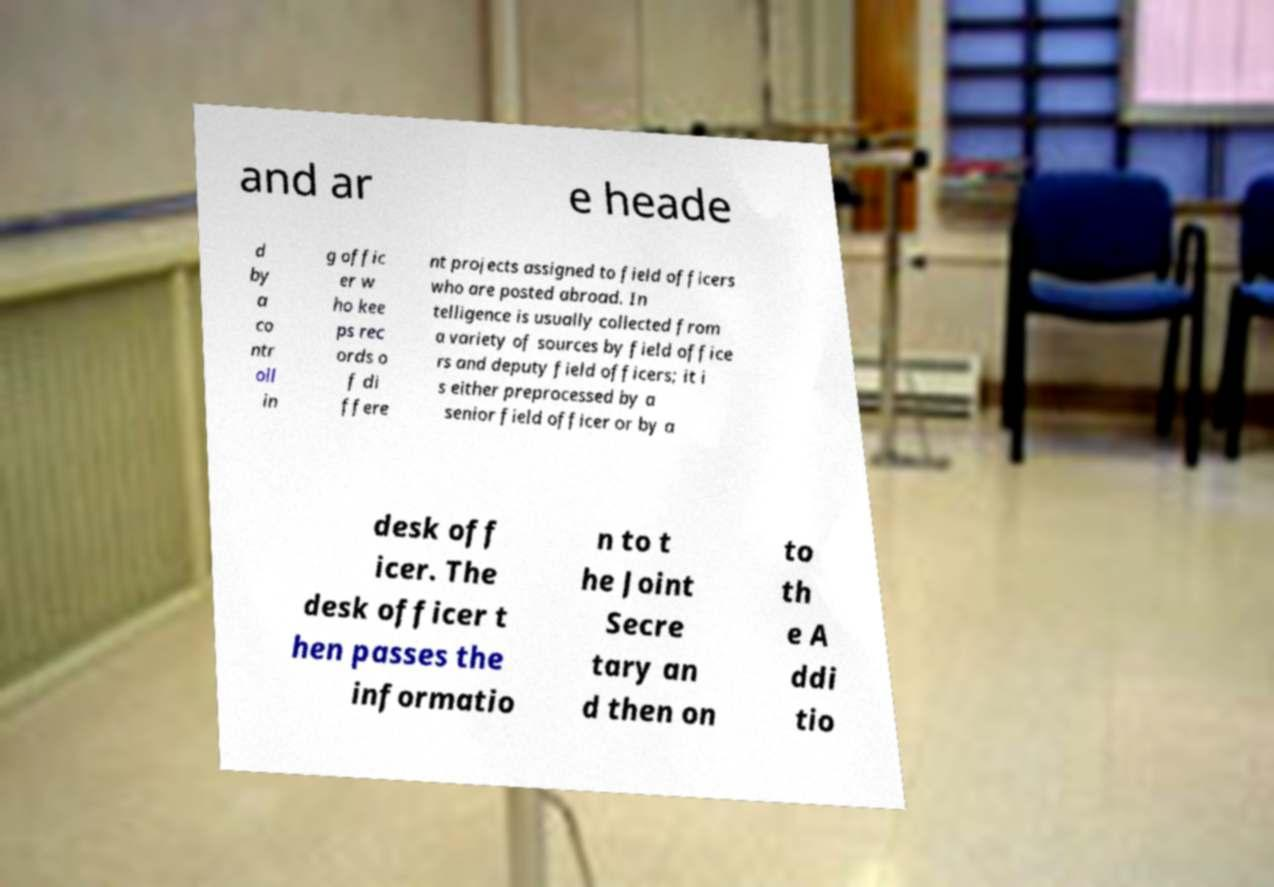There's text embedded in this image that I need extracted. Can you transcribe it verbatim? and ar e heade d by a co ntr oll in g offic er w ho kee ps rec ords o f di ffere nt projects assigned to field officers who are posted abroad. In telligence is usually collected from a variety of sources by field office rs and deputy field officers; it i s either preprocessed by a senior field officer or by a desk off icer. The desk officer t hen passes the informatio n to t he Joint Secre tary an d then on to th e A ddi tio 